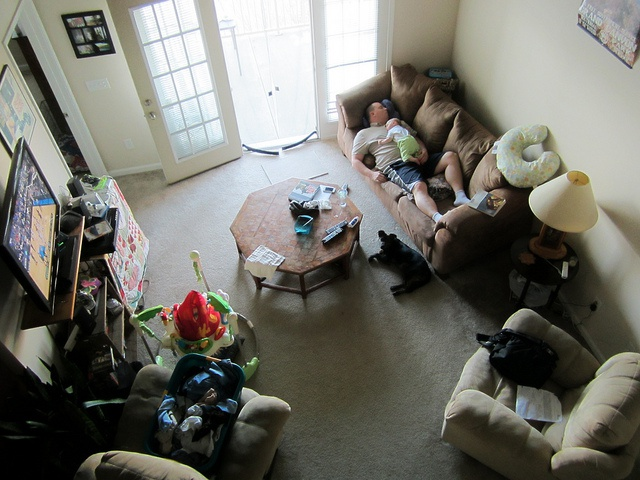Describe the objects in this image and their specific colors. I can see chair in darkgray, black, and gray tones, couch in darkgray, black, and gray tones, chair in darkgray, black, and gray tones, dining table in darkgray, lightgray, black, and gray tones, and people in darkgray, black, and gray tones in this image. 